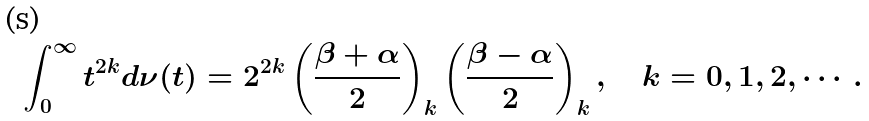<formula> <loc_0><loc_0><loc_500><loc_500>\int _ { 0 } ^ { \infty } t ^ { 2 k } d \nu ( t ) = 2 ^ { 2 k } \left ( \frac { \beta + \alpha } { 2 } \right ) _ { k } \left ( \frac { \beta - \alpha } { 2 } \right ) _ { k } , \quad k = 0 , 1 , 2 , \cdots .</formula> 